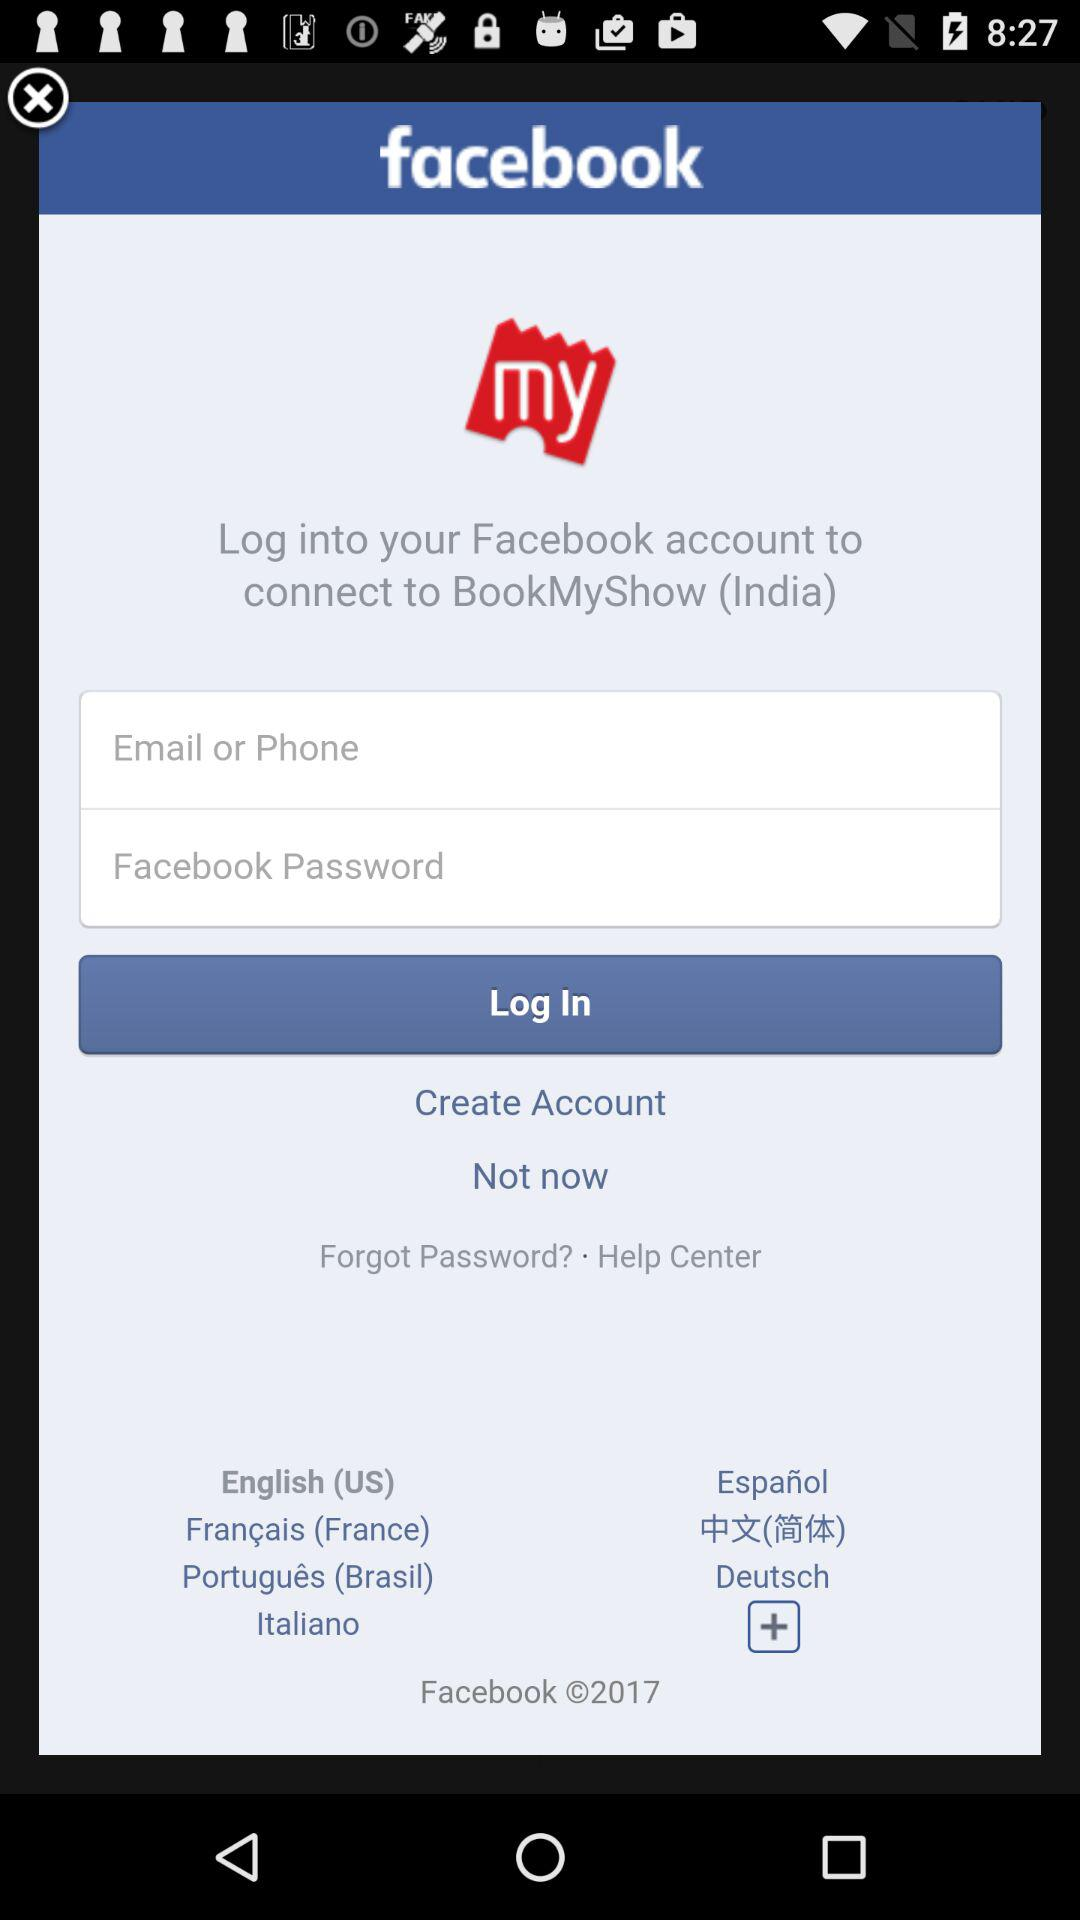How many text fields are there on this screen?
Answer the question using a single word or phrase. 2 